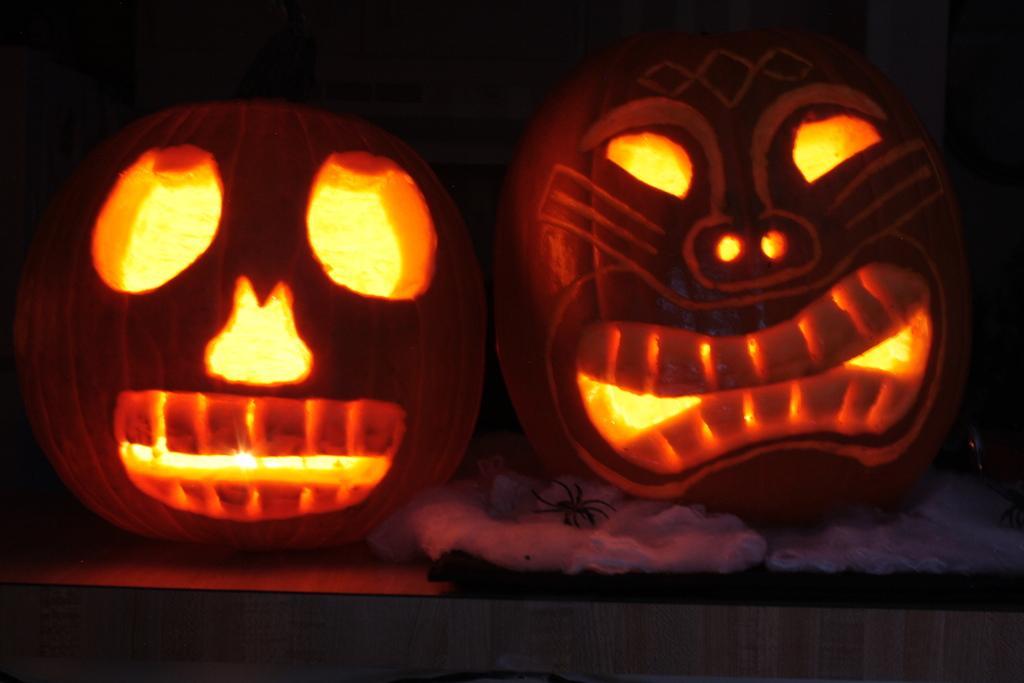Please provide a concise description of this image. This image consists of pumpkins which are carved. And we can see the lights, are kept on the desk. Below the pumpkin, we can see an object, which looks like a cotton pad. 